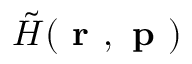<formula> <loc_0><loc_0><loc_500><loc_500>\tilde { H } ( r , p )</formula> 